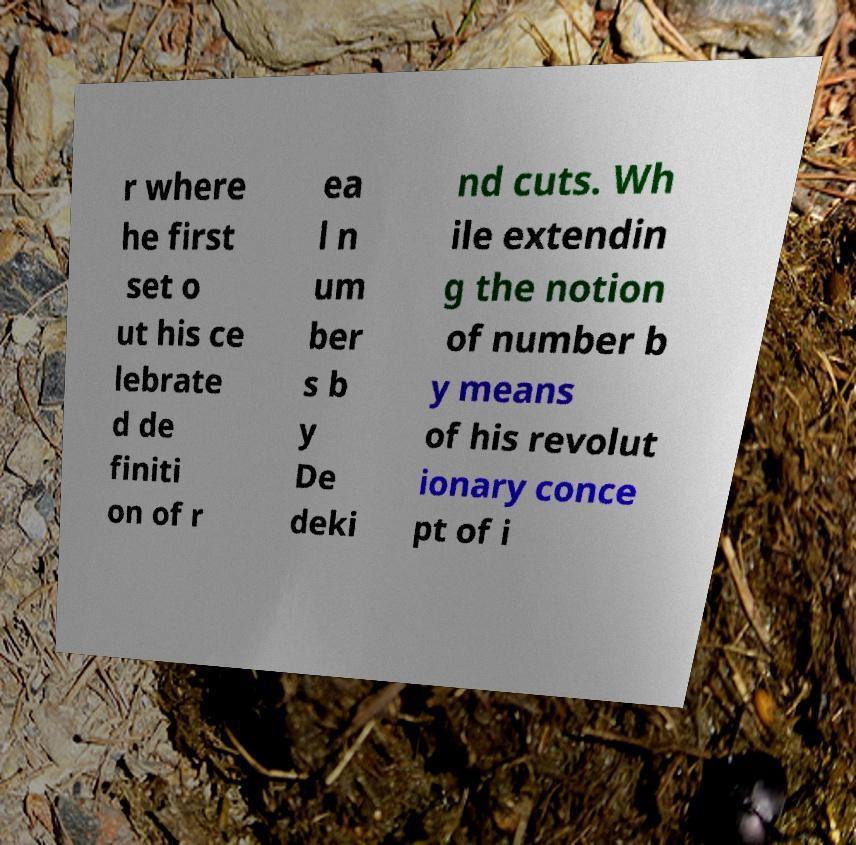Can you read and provide the text displayed in the image?This photo seems to have some interesting text. Can you extract and type it out for me? r where he first set o ut his ce lebrate d de finiti on of r ea l n um ber s b y De deki nd cuts. Wh ile extendin g the notion of number b y means of his revolut ionary conce pt of i 